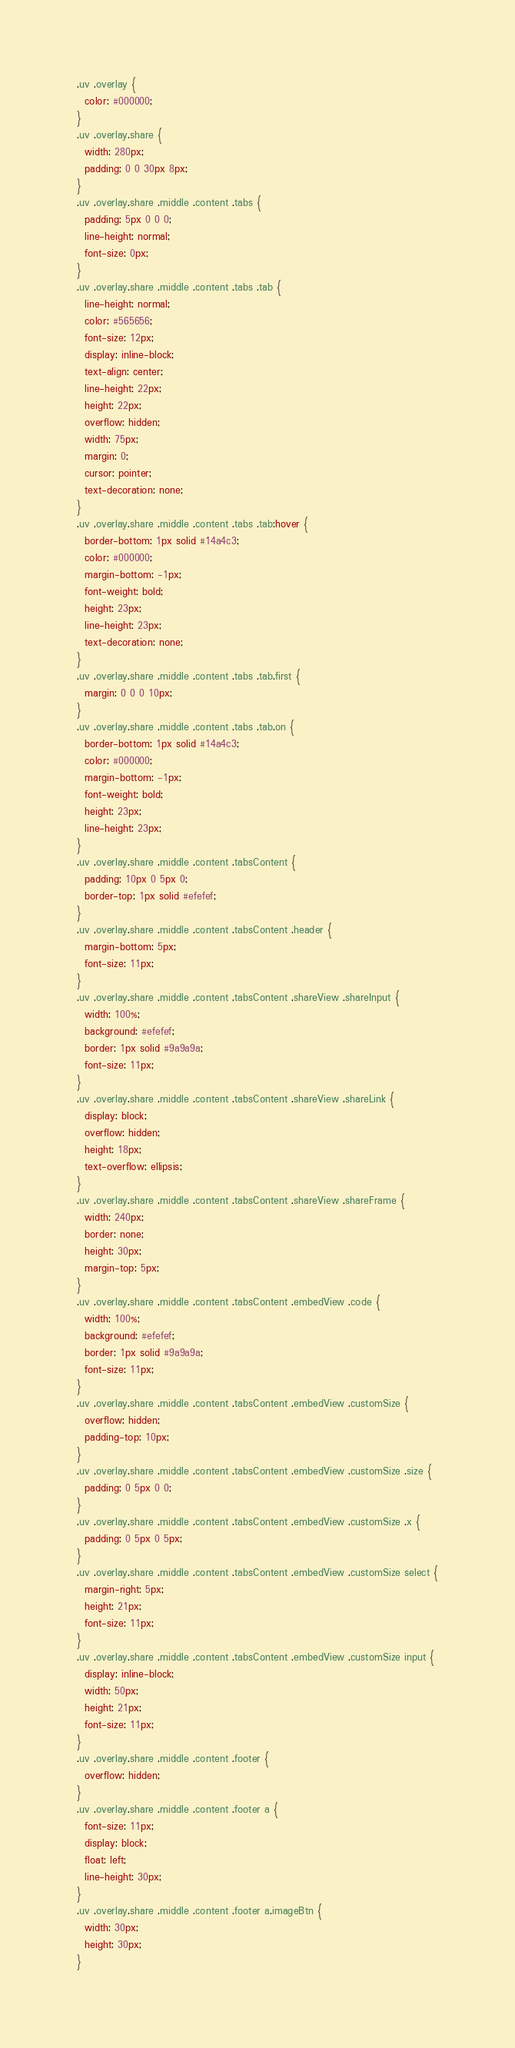Convert code to text. <code><loc_0><loc_0><loc_500><loc_500><_CSS_>.uv .overlay {
  color: #000000;
}
.uv .overlay.share {
  width: 280px;
  padding: 0 0 30px 8px;
}
.uv .overlay.share .middle .content .tabs {
  padding: 5px 0 0 0;
  line-height: normal;
  font-size: 0px;
}
.uv .overlay.share .middle .content .tabs .tab {
  line-height: normal;
  color: #565656;
  font-size: 12px;
  display: inline-block;
  text-align: center;
  line-height: 22px;
  height: 22px;
  overflow: hidden;
  width: 75px;
  margin: 0;
  cursor: pointer;
  text-decoration: none;
}
.uv .overlay.share .middle .content .tabs .tab:hover {
  border-bottom: 1px solid #14a4c3;
  color: #000000;
  margin-bottom: -1px;
  font-weight: bold;
  height: 23px;
  line-height: 23px;
  text-decoration: none;
}
.uv .overlay.share .middle .content .tabs .tab.first {
  margin: 0 0 0 10px;
}
.uv .overlay.share .middle .content .tabs .tab.on {
  border-bottom: 1px solid #14a4c3;
  color: #000000;
  margin-bottom: -1px;
  font-weight: bold;
  height: 23px;
  line-height: 23px;
}
.uv .overlay.share .middle .content .tabsContent {
  padding: 10px 0 5px 0;
  border-top: 1px solid #efefef;
}
.uv .overlay.share .middle .content .tabsContent .header {
  margin-bottom: 5px;
  font-size: 11px;
}
.uv .overlay.share .middle .content .tabsContent .shareView .shareInput {
  width: 100%;
  background: #efefef;
  border: 1px solid #9a9a9a;
  font-size: 11px;
}
.uv .overlay.share .middle .content .tabsContent .shareView .shareLink {
  display: block;
  overflow: hidden;
  height: 18px;
  text-overflow: ellipsis;
}
.uv .overlay.share .middle .content .tabsContent .shareView .shareFrame {
  width: 240px;
  border: none;
  height: 30px;
  margin-top: 5px;
}
.uv .overlay.share .middle .content .tabsContent .embedView .code {
  width: 100%;
  background: #efefef;
  border: 1px solid #9a9a9a;
  font-size: 11px;
}
.uv .overlay.share .middle .content .tabsContent .embedView .customSize {
  overflow: hidden;
  padding-top: 10px;
}
.uv .overlay.share .middle .content .tabsContent .embedView .customSize .size {
  padding: 0 5px 0 0;
}
.uv .overlay.share .middle .content .tabsContent .embedView .customSize .x {
  padding: 0 5px 0 5px;
}
.uv .overlay.share .middle .content .tabsContent .embedView .customSize select {
  margin-right: 5px;
  height: 21px;
  font-size: 11px;
}
.uv .overlay.share .middle .content .tabsContent .embedView .customSize input {
  display: inline-block;
  width: 50px;
  height: 21px;
  font-size: 11px;
}
.uv .overlay.share .middle .content .footer {
  overflow: hidden;
}
.uv .overlay.share .middle .content .footer a {
  font-size: 11px;
  display: block;
  float: left;
  line-height: 30px;
}
.uv .overlay.share .middle .content .footer a.imageBtn {
  width: 30px;
  height: 30px;
}</code> 